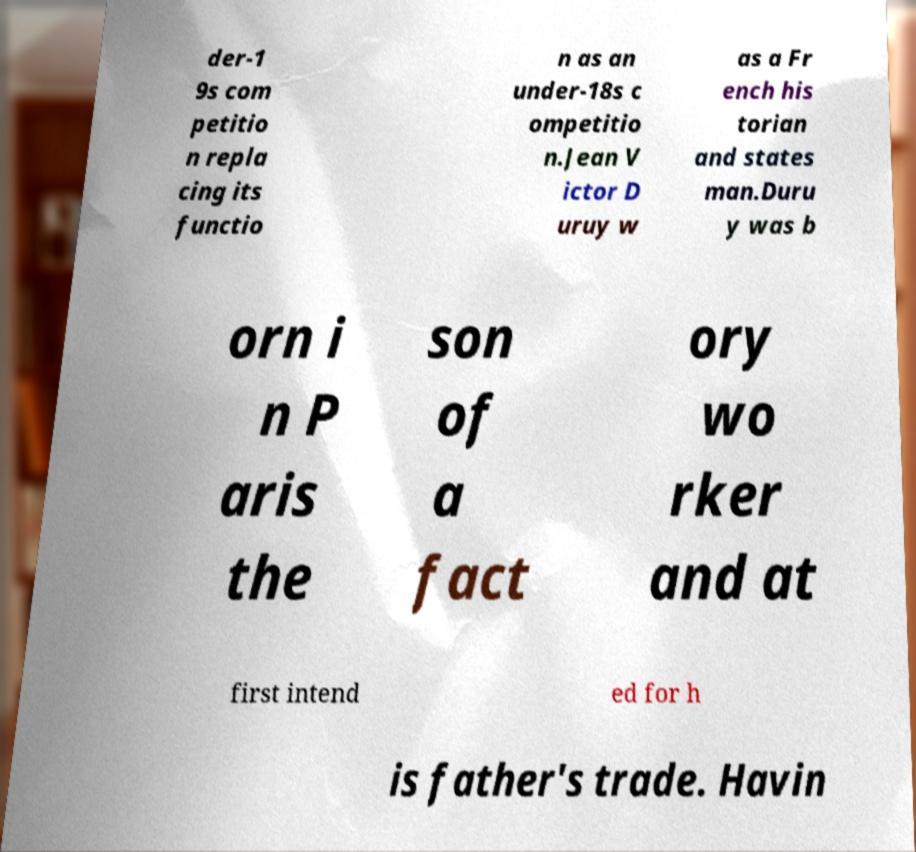I need the written content from this picture converted into text. Can you do that? der-1 9s com petitio n repla cing its functio n as an under-18s c ompetitio n.Jean V ictor D uruy w as a Fr ench his torian and states man.Duru y was b orn i n P aris the son of a fact ory wo rker and at first intend ed for h is father's trade. Havin 